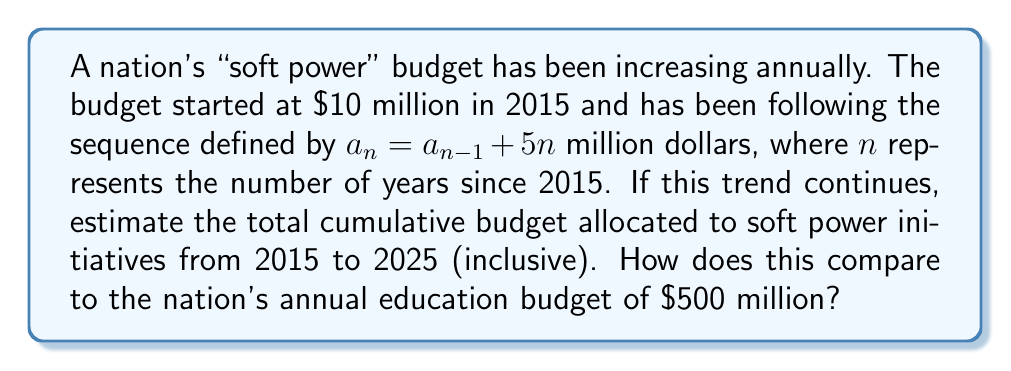What is the answer to this math problem? Let's approach this step-by-step:

1) First, let's calculate the budget for each year from 2015 to 2025:

   2015 (n=0): $a_0 = 10$ million
   2016 (n=1): $a_1 = a_0 + 5(1) = 10 + 5 = 15$ million
   2017 (n=2): $a_2 = a_1 + 5(2) = 15 + 10 = 25$ million
   2018 (n=3): $a_3 = a_2 + 5(3) = 25 + 15 = 40$ million
   ...and so on.

2) We can express this as an arithmetic sequence with a variable common difference:
   $a_n = a_0 + \sum_{i=1}^n 5i$

3) The sum of the first n positive integers is given by the formula:
   $\sum_{i=1}^n i = \frac{n(n+1)}{2}$

4) Therefore, we can simplify our sequence to:
   $a_n = 10 + 5 \cdot \frac{n(n+1)}{2} = 10 + \frac{5n(n+1)}{2}$

5) Now, let's calculate the value for 2025 (n=10):
   $a_{10} = 10 + \frac{5 \cdot 10(10+1)}{2} = 10 + 275 = 285$ million

6) To find the total cumulative budget, we need to sum all values from 2015 to 2025:
   $S = \sum_{n=0}^{10} a_n = \sum_{n=0}^{10} (10 + \frac{5n(n+1)}{2})$

7) This sum can be calculated as:
   $S = 11 \cdot 10 + 5 \cdot \sum_{n=0}^{10} \frac{n(n+1)}{2}$

8) The sum $\sum_{n=0}^{10} \frac{n(n+1)}{2}$ is equal to $\frac{10 \cdot 11 \cdot 21}{6} = 385$

9) Therefore, the total cumulative budget is:
   $S = 110 + 5 \cdot 385 = 2035$ million dollars

10) Comparing to the annual education budget:
    $\frac{2035}{500} \approx 4.07$

This means the cumulative soft power budget over 11 years is about 4.07 times the annual education budget.
Answer: $2035 million; 4.07 times the annual education budget 